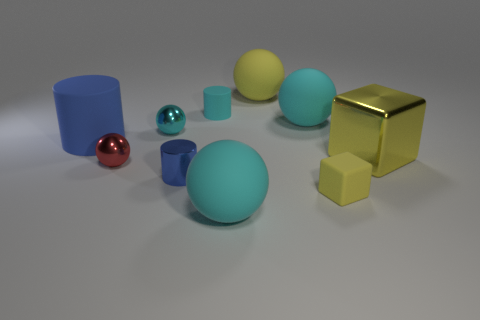There is a block that is the same color as the large metallic thing; what is its material?
Ensure brevity in your answer.  Rubber. The big object that is in front of the tiny blue shiny thing is what color?
Give a very brief answer. Cyan. What is the size of the matte object that is behind the small cylinder behind the big yellow metallic thing?
Ensure brevity in your answer.  Large. There is a yellow thing that is right of the tiny block; does it have the same shape as the cyan metal object?
Ensure brevity in your answer.  No. What is the material of the other yellow thing that is the same shape as the yellow metallic object?
Offer a terse response. Rubber. How many things are large matte balls that are behind the blue metal object or matte things that are to the left of the blue metal cylinder?
Provide a short and direct response. 3. There is a small metal cylinder; is it the same color as the large matte thing to the left of the red metallic ball?
Give a very brief answer. Yes. What is the shape of the small cyan thing that is the same material as the small blue object?
Offer a very short reply. Sphere. What number of brown things are there?
Make the answer very short. 0. How many things are small things in front of the big metallic block or blue shiny objects?
Ensure brevity in your answer.  3. 